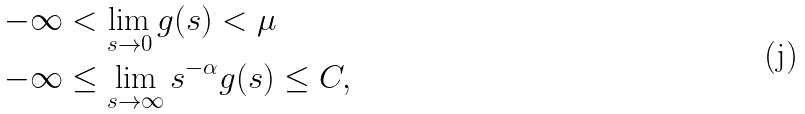Convert formula to latex. <formula><loc_0><loc_0><loc_500><loc_500>- \infty & < \lim _ { s \rightarrow 0 } g ( s ) < \mu \\ - \infty & \leq \lim _ { s \rightarrow \infty } s ^ { - \alpha } g ( s ) \leq C ,</formula> 